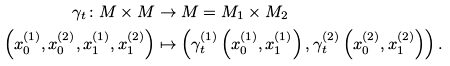Convert formula to latex. <formula><loc_0><loc_0><loc_500><loc_500>\gamma _ { t } \colon M \times M & \rightarrow M = M _ { 1 } \times M _ { 2 } \\ \left ( x ^ { ( 1 ) } _ { 0 } , x ^ { ( 2 ) } _ { 0 } , x ^ { ( 1 ) } _ { 1 } , x ^ { ( 2 ) } _ { 1 } \right ) & \mapsto \left ( \gamma ^ { ( 1 ) } _ { t } \left ( x ^ { ( 1 ) } _ { 0 } , x ^ { ( 1 ) } _ { 1 } \right ) , \gamma ^ { ( 2 ) } _ { t } \left ( x ^ { ( 2 ) } _ { 0 } , x ^ { ( 2 ) } _ { 1 } \right ) \right ) .</formula> 